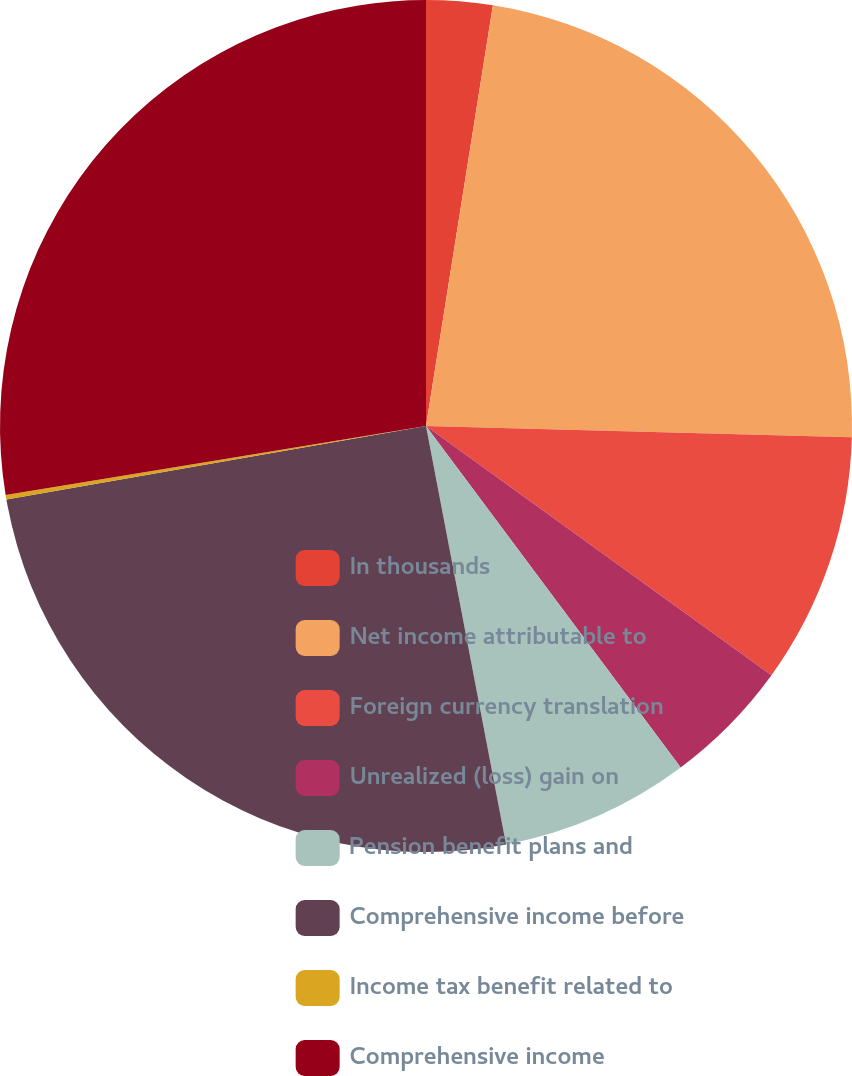<chart> <loc_0><loc_0><loc_500><loc_500><pie_chart><fcel>In thousands<fcel>Net income attributable to<fcel>Foreign currency translation<fcel>Unrealized (loss) gain on<fcel>Pension benefit plans and<fcel>Comprehensive income before<fcel>Income tax benefit related to<fcel>Comprehensive income<nl><fcel>2.51%<fcel>22.91%<fcel>9.53%<fcel>4.85%<fcel>7.19%<fcel>25.25%<fcel>0.17%<fcel>27.59%<nl></chart> 